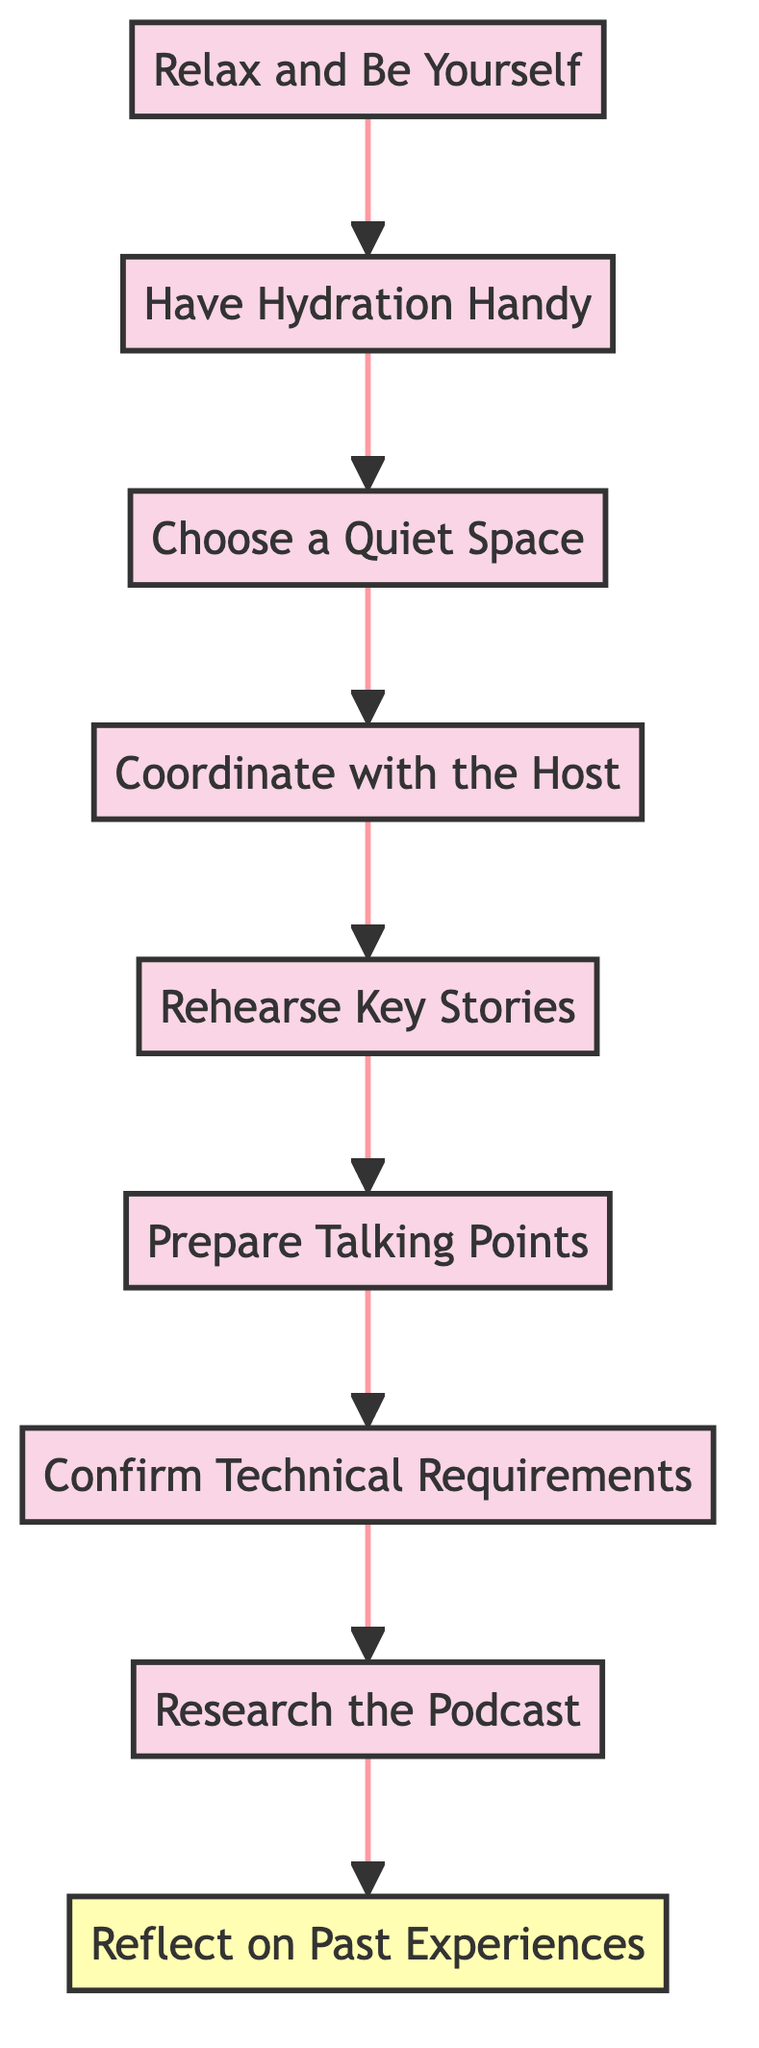What is the first step in the preparation process? The bottommost node in the diagram indicates that the first step to take is "Relax and Be Yourself."
Answer: Relax and Be Yourself How many nodes are there in total in the diagram? By counting each distinct action or step represented in the diagram, there are a total of 9 nodes from "Relax and Be Yourself" to "Reflect on Past Experiences."
Answer: 9 What is the last step before confirming technical requirements? Moving upwards through the diagram, the step just before "Confirm Technical Requirements" is "Prepare Talking Points."
Answer: Prepare Talking Points Which step involves rehearsal? The specific node detailing the rehearsal activity is labelled "Rehearse Key Stories."
Answer: Rehearse Key Stories What is the relationship between "Research the Podcast" and "Reflect on Past Experiences"? "Research the Podcast" directly precedes "Reflect on Past Experiences" in the upward flow of the diagram.
Answer: Research the Podcast precedes Reflect on Past Experiences What should you have handy during the podcast recording? Referring to the node, it states that "Have Hydration Handy" is essential during the recording.
Answer: Have Hydration Handy What is the last node in the preparation flow? The last node at the top of the diagram represents "Reflect on Past Experiences," indicating it is the final aspect to consider.
Answer: Reflect on Past Experiences How many steps are there before selecting a quiet space? Counting upwards, there are three steps ("Have Hydration Handy," "Choose a Quiet Space," "Coordinate with the Host") before reaching "Choose a Quiet Space."
Answer: 3 Which step should be done after coordinating with the host? According to the flow, the step that follows "Coordinate with the Host" is "Rehearse Key Stories."
Answer: Rehearse Key Stories 